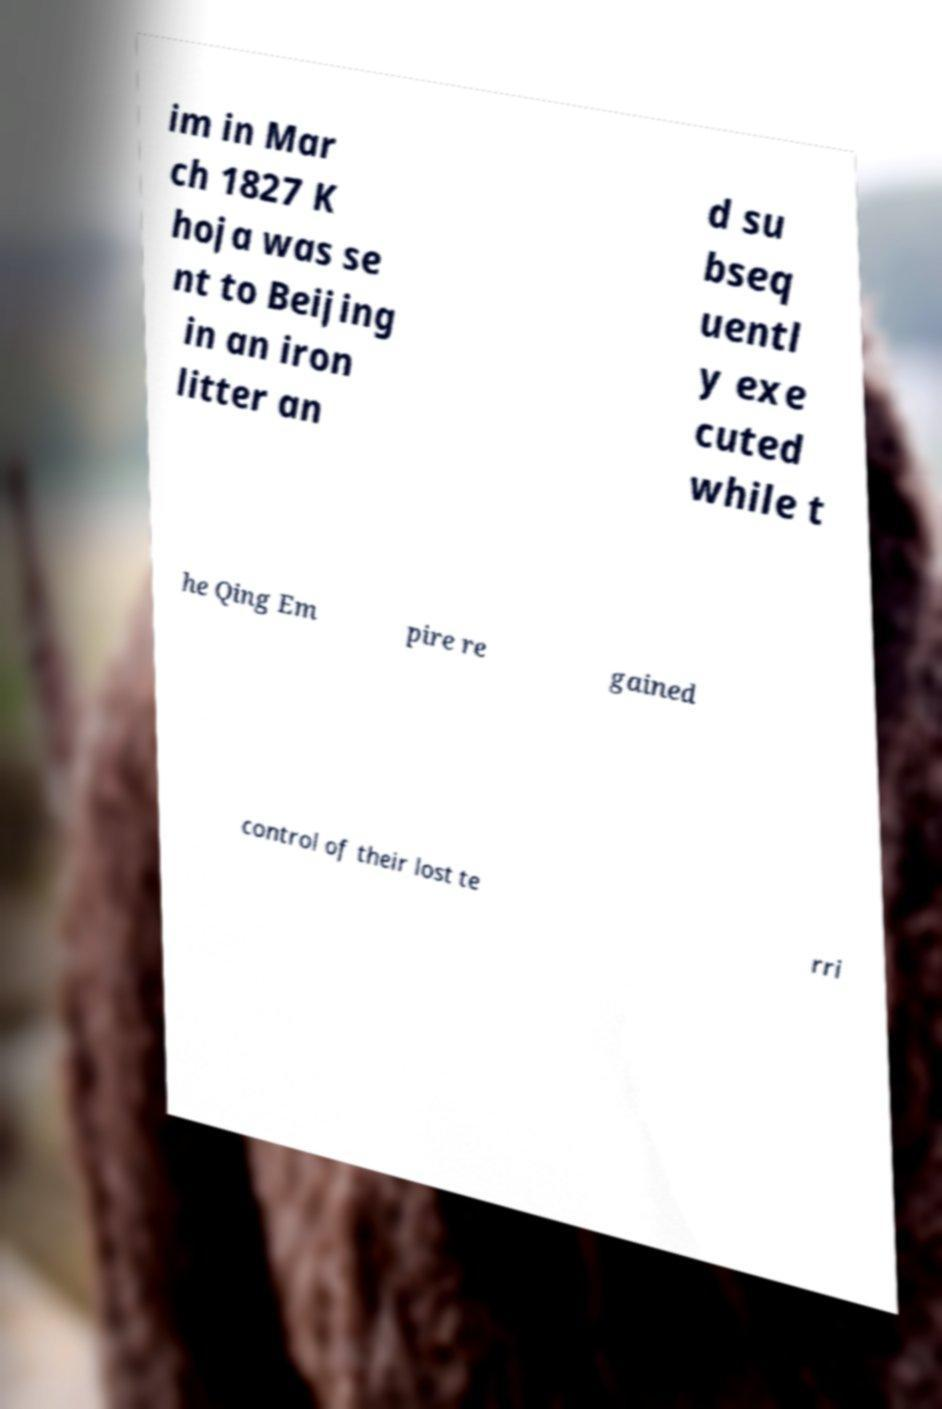Could you extract and type out the text from this image? im in Mar ch 1827 K hoja was se nt to Beijing in an iron litter an d su bseq uentl y exe cuted while t he Qing Em pire re gained control of their lost te rri 